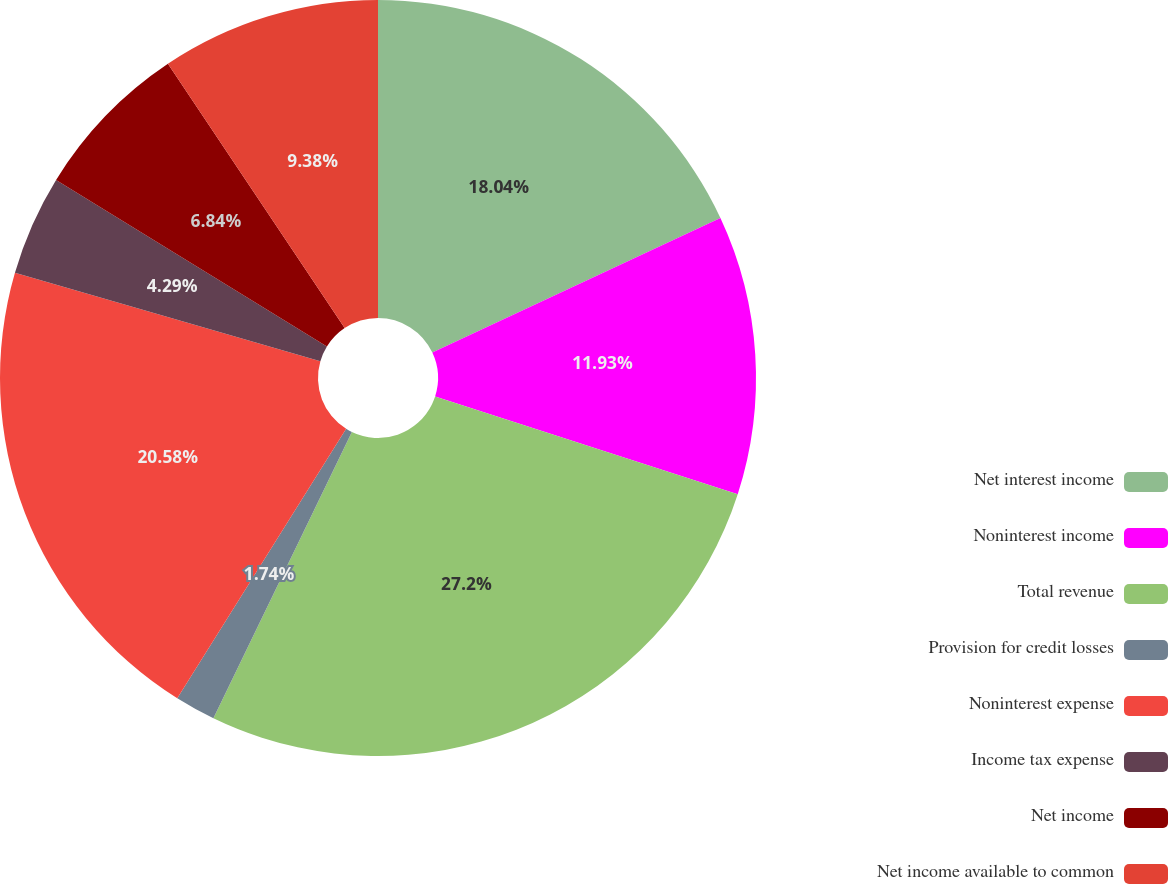Convert chart. <chart><loc_0><loc_0><loc_500><loc_500><pie_chart><fcel>Net interest income<fcel>Noninterest income<fcel>Total revenue<fcel>Provision for credit losses<fcel>Noninterest expense<fcel>Income tax expense<fcel>Net income<fcel>Net income available to common<nl><fcel>18.04%<fcel>11.93%<fcel>27.2%<fcel>1.74%<fcel>20.58%<fcel>4.29%<fcel>6.84%<fcel>9.38%<nl></chart> 